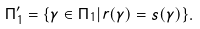Convert formula to latex. <formula><loc_0><loc_0><loc_500><loc_500>\Pi _ { 1 } ^ { \prime } = \{ \gamma \in \Pi _ { 1 } | r ( \gamma ) = s ( \gamma ) \} .</formula> 